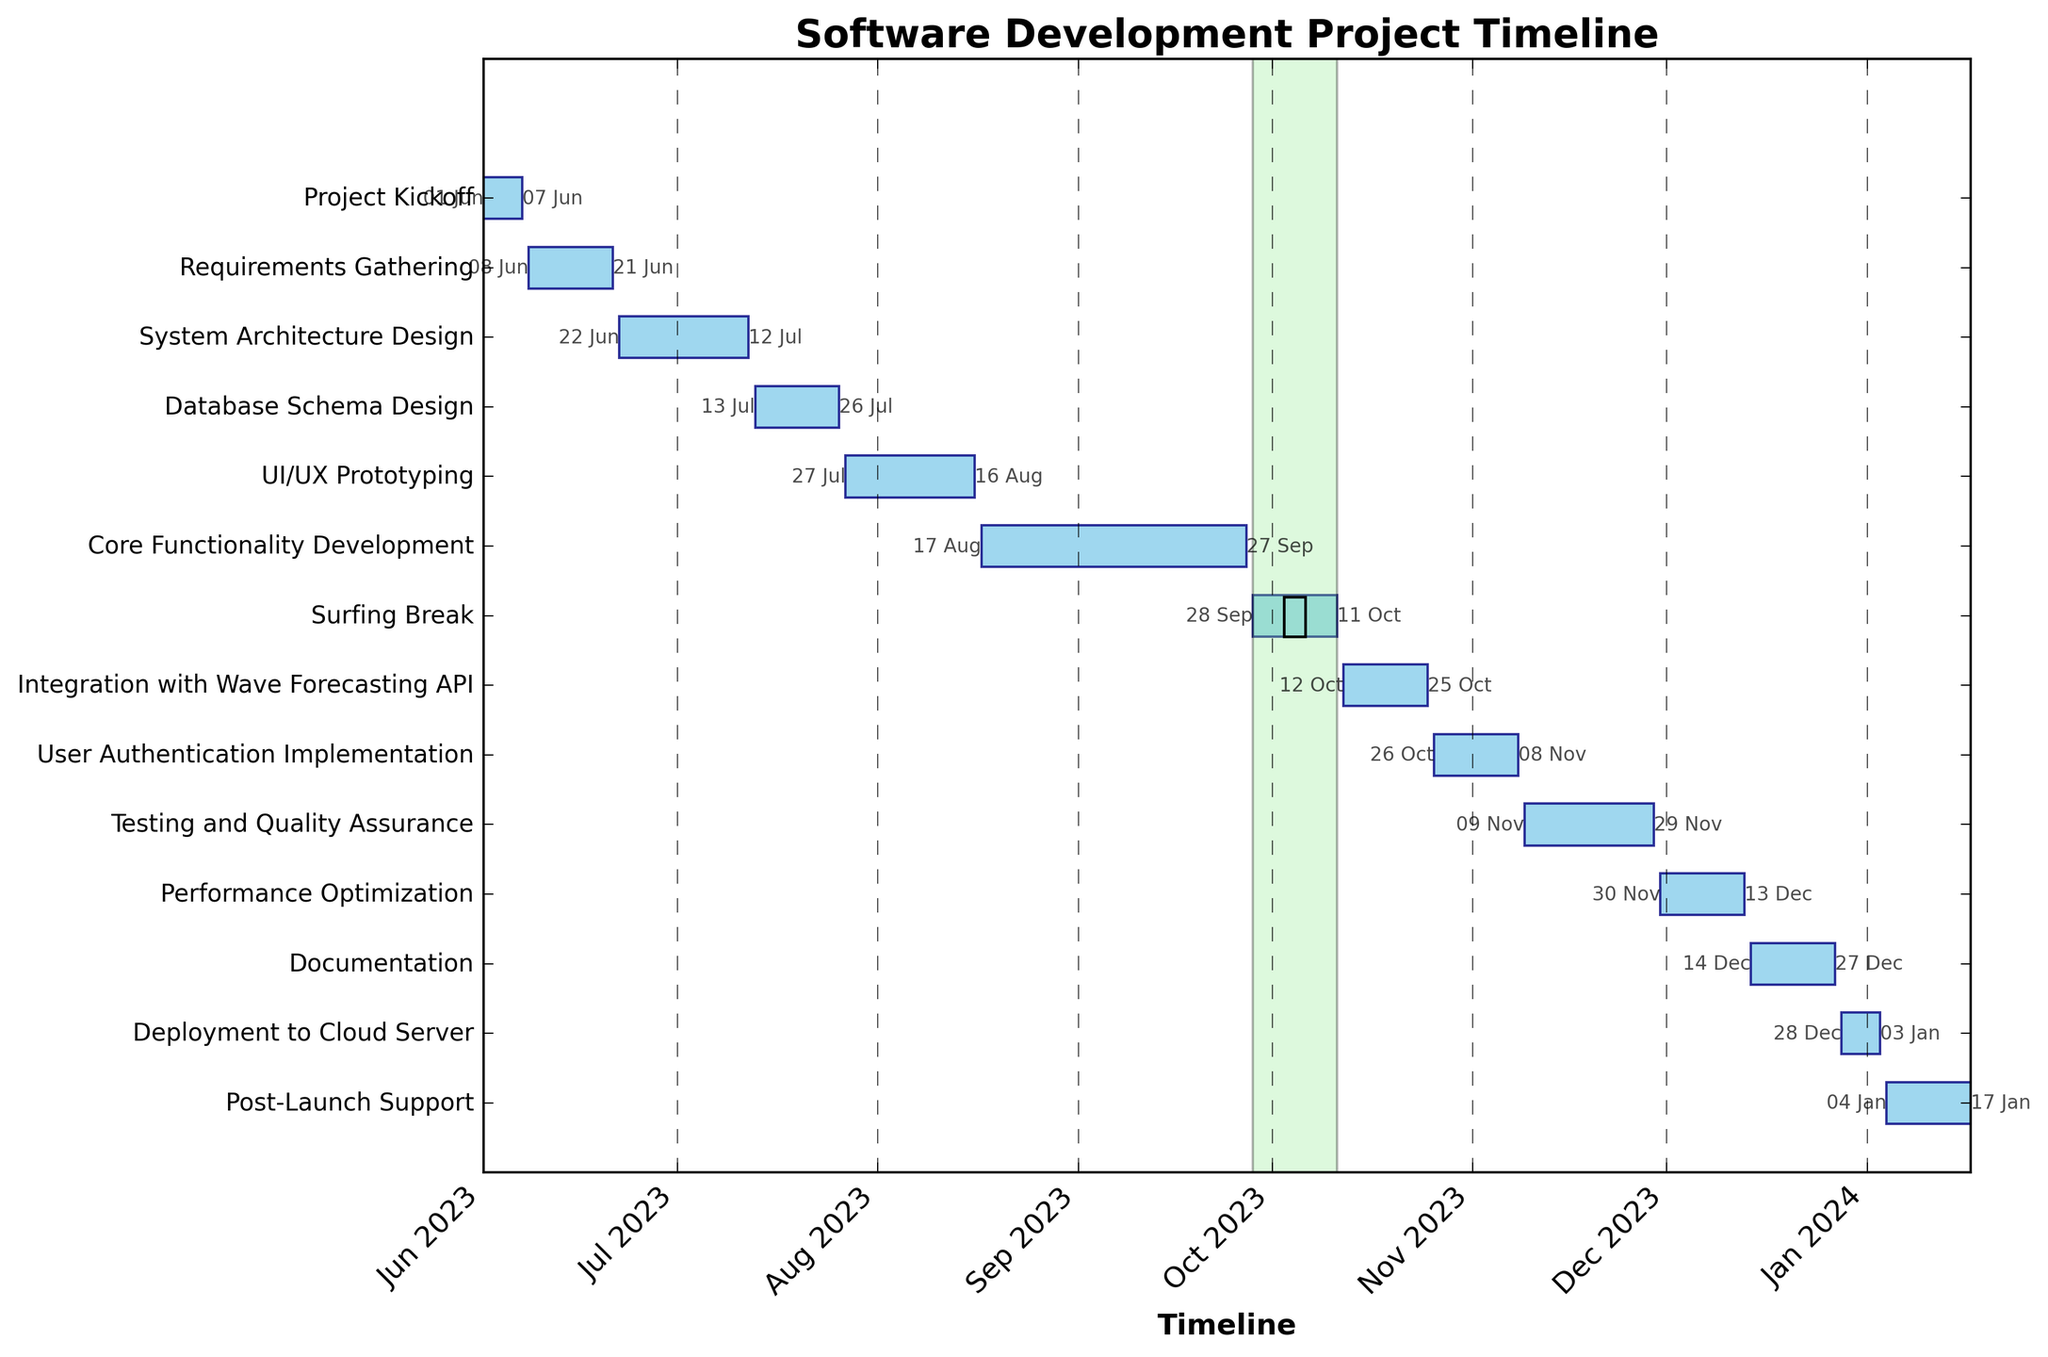How long is the "System Architecture Design" phase? To find the duration of the "System Architecture Design" phase, look at the timeline bar for this task, or calculate the difference between the start date (June 22, 2023) and the end date (July 12, 2023). The phase spans 21 days.
Answer: 21 days Which task takes the longest time to complete? Identify the task with the longest horizontal bar representing its duration. The "Core Functionality Development" phase has the longest duration, spanning from August 17, 2023, to September 27, 2023 (42 days).
Answer: Core Functionality Development What is the start date for the "Testing and Quality Assurance" phase? Look at the beginning of the horizontal bar for "Testing and Quality Assurance" to find its start date. It starts on November 9, 2023.
Answer: November 9, 2023 Which phase is scheduled immediately after the "Surfing Break"? Check the end date of the "Surfing Break" and see which task starts immediately after. The "Integration with Wave Forecasting API" begins right after, starting on October 12, 2023.
Answer: Integration with Wave Forecasting API How long does the "Deployment to Cloud Server" take? Calculate the duration of "Deployment to Cloud Server" by checking its bar or subtracting its start date (December 28, 2023) from its end date (January 3, 2024). It lasts for 7 days.
Answer: 7 days Which two phases overlap with the "Surfing Break"? Identify phases whose timelines intersect with the "Surfing Break" from September 28, 2023, to October 11, 2023. No phases completely overlap, as tasks are either before or after it.
Answer: None What is the total duration from the project kickoff to the end of post-launch support? Calculate the duration from the project kickoff (June 1, 2023) to the end of post-launch support (January 17, 2024). This totals 230 days.
Answer: 230 days Between "Database Schema Design" and "UI/UX Prototyping," which one ends later? Compare the end dates of these two phases: "Database Schema Design" ends on July 26, 2023, while "UI/UX Prototyping" ends on August 16, 2023. The latter ends later.
Answer: UI/UX Prototyping How many tasks take place in the month of October? Examine the timeline bars and count the number of tasks that are active in October. "Surfing Break," "Integration with Wave Forecasting API," and "User Authentication Implementation" take place in October, totaling 3 tasks.
Answer: 3 tasks What is depicted by the green highlighted section in the chart? Refer to the description focusing on visual elements. The green highlighted section represents the "Surfing Break" duration, as indicated by its unique coloring and wave icon.
Answer: Surfing Break 